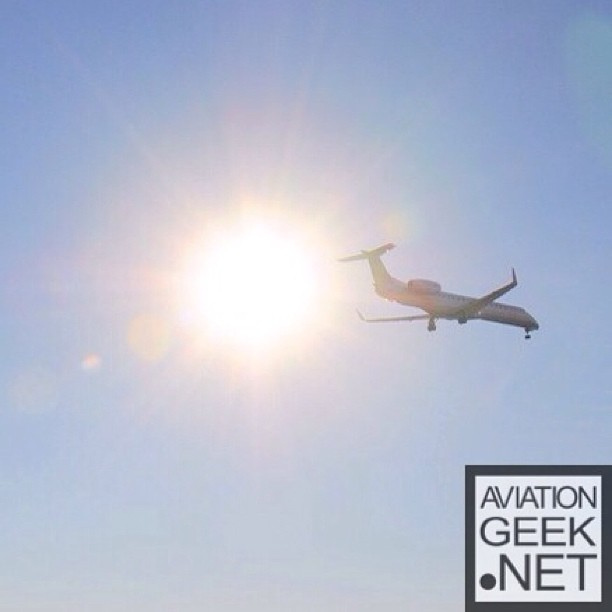<image>Are there clouds? The question is ambiguous as there is no image to refer to for the presence of clouds. Are there clouds? There are no clouds in the image. 